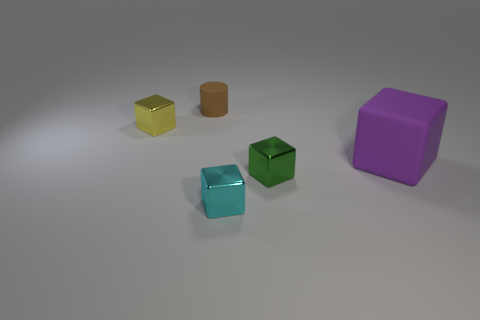There is a small thing that is behind the yellow metallic thing; is there a green shiny object behind it?
Keep it short and to the point. No. How many objects are blocks that are behind the tiny cyan metallic thing or small yellow objects?
Your answer should be compact. 3. How many large gray matte blocks are there?
Provide a short and direct response. 0. What is the shape of the brown thing that is the same material as the purple block?
Offer a very short reply. Cylinder. How big is the rubber thing behind the small metal object behind the large purple matte block?
Your answer should be compact. Small. How many objects are tiny metallic things that are in front of the tiny green metal block or tiny metal blocks that are behind the small cyan metallic block?
Keep it short and to the point. 3. Is the number of tiny cylinders less than the number of tiny blue rubber cubes?
Offer a very short reply. No. How many objects are either red blocks or small objects?
Your response must be concise. 4. Does the small matte thing have the same shape as the small yellow metal object?
Your response must be concise. No. Is there any other thing that has the same material as the purple thing?
Your answer should be compact. Yes. 